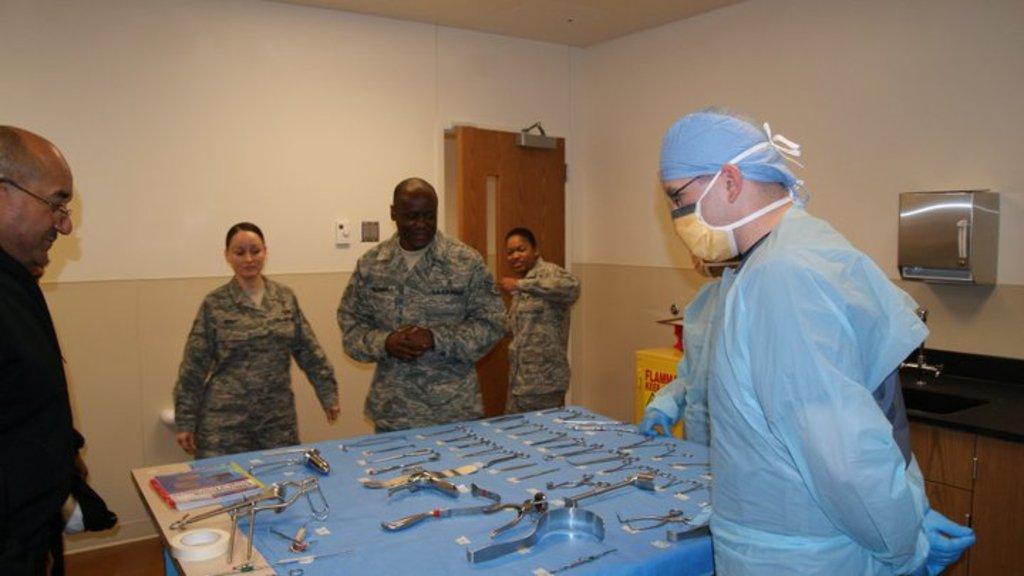Please provide a concise description of this image. In the center of the image we can see surgery instruments placed on the table and we can see also see person standing around the table. On the right side of the image we can see tissue dispenser, sink and tap. In the background we can see wall, door and switch board. 